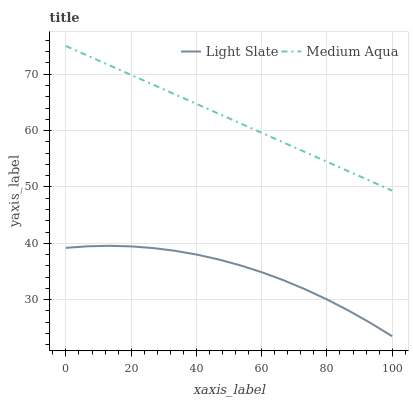Does Light Slate have the minimum area under the curve?
Answer yes or no. Yes. Does Medium Aqua have the maximum area under the curve?
Answer yes or no. Yes. Does Medium Aqua have the minimum area under the curve?
Answer yes or no. No. Is Medium Aqua the smoothest?
Answer yes or no. Yes. Is Light Slate the roughest?
Answer yes or no. Yes. Is Medium Aqua the roughest?
Answer yes or no. No. Does Light Slate have the lowest value?
Answer yes or no. Yes. Does Medium Aqua have the lowest value?
Answer yes or no. No. Does Medium Aqua have the highest value?
Answer yes or no. Yes. Is Light Slate less than Medium Aqua?
Answer yes or no. Yes. Is Medium Aqua greater than Light Slate?
Answer yes or no. Yes. Does Light Slate intersect Medium Aqua?
Answer yes or no. No. 